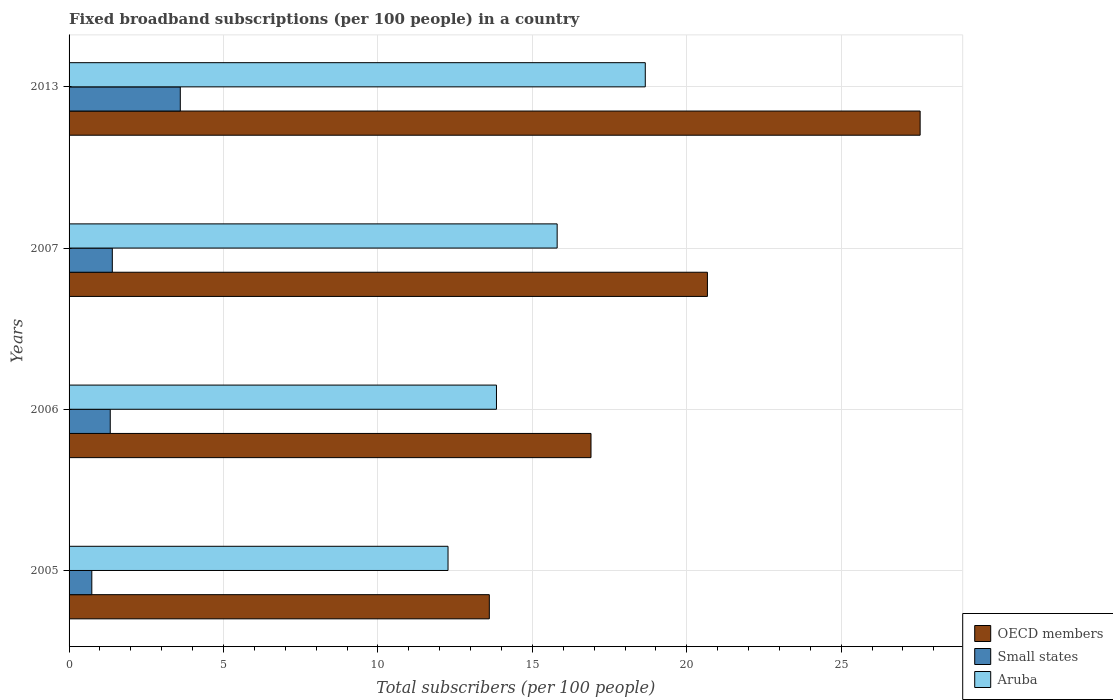How many groups of bars are there?
Offer a terse response. 4. How many bars are there on the 4th tick from the top?
Make the answer very short. 3. What is the label of the 1st group of bars from the top?
Your answer should be very brief. 2013. In how many cases, is the number of bars for a given year not equal to the number of legend labels?
Offer a terse response. 0. What is the number of broadband subscriptions in OECD members in 2006?
Your answer should be compact. 16.9. Across all years, what is the maximum number of broadband subscriptions in Aruba?
Make the answer very short. 18.66. Across all years, what is the minimum number of broadband subscriptions in OECD members?
Offer a terse response. 13.61. In which year was the number of broadband subscriptions in Small states maximum?
Your answer should be compact. 2013. In which year was the number of broadband subscriptions in Aruba minimum?
Make the answer very short. 2005. What is the total number of broadband subscriptions in Aruba in the graph?
Provide a short and direct response. 60.57. What is the difference between the number of broadband subscriptions in Small states in 2005 and that in 2013?
Give a very brief answer. -2.86. What is the difference between the number of broadband subscriptions in OECD members in 2006 and the number of broadband subscriptions in Small states in 2005?
Offer a terse response. 16.16. What is the average number of broadband subscriptions in OECD members per year?
Your answer should be compact. 19.68. In the year 2013, what is the difference between the number of broadband subscriptions in Aruba and number of broadband subscriptions in OECD members?
Ensure brevity in your answer.  -8.9. What is the ratio of the number of broadband subscriptions in Aruba in 2005 to that in 2007?
Offer a terse response. 0.78. Is the number of broadband subscriptions in Small states in 2006 less than that in 2013?
Make the answer very short. Yes. What is the difference between the highest and the second highest number of broadband subscriptions in Aruba?
Give a very brief answer. 2.85. What is the difference between the highest and the lowest number of broadband subscriptions in Aruba?
Your answer should be very brief. 6.39. Is the sum of the number of broadband subscriptions in OECD members in 2006 and 2007 greater than the maximum number of broadband subscriptions in Aruba across all years?
Keep it short and to the point. Yes. What does the 1st bar from the top in 2007 represents?
Your answer should be very brief. Aruba. Is it the case that in every year, the sum of the number of broadband subscriptions in OECD members and number of broadband subscriptions in Aruba is greater than the number of broadband subscriptions in Small states?
Your answer should be compact. Yes. Are all the bars in the graph horizontal?
Your answer should be very brief. Yes. What is the difference between two consecutive major ticks on the X-axis?
Make the answer very short. 5. Does the graph contain any zero values?
Keep it short and to the point. No. How many legend labels are there?
Your answer should be compact. 3. How are the legend labels stacked?
Your answer should be very brief. Vertical. What is the title of the graph?
Your answer should be very brief. Fixed broadband subscriptions (per 100 people) in a country. Does "Ireland" appear as one of the legend labels in the graph?
Offer a very short reply. No. What is the label or title of the X-axis?
Keep it short and to the point. Total subscribers (per 100 people). What is the Total subscribers (per 100 people) of OECD members in 2005?
Provide a succinct answer. 13.61. What is the Total subscribers (per 100 people) in Small states in 2005?
Provide a succinct answer. 0.74. What is the Total subscribers (per 100 people) in Aruba in 2005?
Make the answer very short. 12.27. What is the Total subscribers (per 100 people) in OECD members in 2006?
Offer a very short reply. 16.9. What is the Total subscribers (per 100 people) in Small states in 2006?
Keep it short and to the point. 1.33. What is the Total subscribers (per 100 people) of Aruba in 2006?
Ensure brevity in your answer.  13.84. What is the Total subscribers (per 100 people) of OECD members in 2007?
Your answer should be very brief. 20.67. What is the Total subscribers (per 100 people) of Small states in 2007?
Keep it short and to the point. 1.4. What is the Total subscribers (per 100 people) of Aruba in 2007?
Offer a very short reply. 15.8. What is the Total subscribers (per 100 people) of OECD members in 2013?
Provide a short and direct response. 27.56. What is the Total subscribers (per 100 people) of Small states in 2013?
Ensure brevity in your answer.  3.6. What is the Total subscribers (per 100 people) of Aruba in 2013?
Offer a terse response. 18.66. Across all years, what is the maximum Total subscribers (per 100 people) in OECD members?
Your response must be concise. 27.56. Across all years, what is the maximum Total subscribers (per 100 people) in Small states?
Give a very brief answer. 3.6. Across all years, what is the maximum Total subscribers (per 100 people) of Aruba?
Your answer should be very brief. 18.66. Across all years, what is the minimum Total subscribers (per 100 people) in OECD members?
Provide a succinct answer. 13.61. Across all years, what is the minimum Total subscribers (per 100 people) of Small states?
Your answer should be compact. 0.74. Across all years, what is the minimum Total subscribers (per 100 people) in Aruba?
Ensure brevity in your answer.  12.27. What is the total Total subscribers (per 100 people) of OECD members in the graph?
Your answer should be very brief. 78.73. What is the total Total subscribers (per 100 people) in Small states in the graph?
Make the answer very short. 7.07. What is the total Total subscribers (per 100 people) of Aruba in the graph?
Your answer should be compact. 60.57. What is the difference between the Total subscribers (per 100 people) of OECD members in 2005 and that in 2006?
Offer a very short reply. -3.29. What is the difference between the Total subscribers (per 100 people) in Small states in 2005 and that in 2006?
Offer a terse response. -0.6. What is the difference between the Total subscribers (per 100 people) in Aruba in 2005 and that in 2006?
Provide a short and direct response. -1.57. What is the difference between the Total subscribers (per 100 people) in OECD members in 2005 and that in 2007?
Make the answer very short. -7.06. What is the difference between the Total subscribers (per 100 people) of Small states in 2005 and that in 2007?
Provide a short and direct response. -0.66. What is the difference between the Total subscribers (per 100 people) of Aruba in 2005 and that in 2007?
Your answer should be very brief. -3.53. What is the difference between the Total subscribers (per 100 people) in OECD members in 2005 and that in 2013?
Provide a short and direct response. -13.95. What is the difference between the Total subscribers (per 100 people) of Small states in 2005 and that in 2013?
Provide a succinct answer. -2.87. What is the difference between the Total subscribers (per 100 people) of Aruba in 2005 and that in 2013?
Your answer should be compact. -6.39. What is the difference between the Total subscribers (per 100 people) in OECD members in 2006 and that in 2007?
Give a very brief answer. -3.77. What is the difference between the Total subscribers (per 100 people) of Small states in 2006 and that in 2007?
Provide a short and direct response. -0.07. What is the difference between the Total subscribers (per 100 people) in Aruba in 2006 and that in 2007?
Give a very brief answer. -1.97. What is the difference between the Total subscribers (per 100 people) of OECD members in 2006 and that in 2013?
Your response must be concise. -10.66. What is the difference between the Total subscribers (per 100 people) in Small states in 2006 and that in 2013?
Your answer should be very brief. -2.27. What is the difference between the Total subscribers (per 100 people) in Aruba in 2006 and that in 2013?
Your answer should be compact. -4.82. What is the difference between the Total subscribers (per 100 people) in OECD members in 2007 and that in 2013?
Ensure brevity in your answer.  -6.89. What is the difference between the Total subscribers (per 100 people) of Small states in 2007 and that in 2013?
Offer a very short reply. -2.2. What is the difference between the Total subscribers (per 100 people) in Aruba in 2007 and that in 2013?
Your response must be concise. -2.85. What is the difference between the Total subscribers (per 100 people) in OECD members in 2005 and the Total subscribers (per 100 people) in Small states in 2006?
Ensure brevity in your answer.  12.27. What is the difference between the Total subscribers (per 100 people) of OECD members in 2005 and the Total subscribers (per 100 people) of Aruba in 2006?
Make the answer very short. -0.23. What is the difference between the Total subscribers (per 100 people) in Small states in 2005 and the Total subscribers (per 100 people) in Aruba in 2006?
Make the answer very short. -13.1. What is the difference between the Total subscribers (per 100 people) of OECD members in 2005 and the Total subscribers (per 100 people) of Small states in 2007?
Provide a succinct answer. 12.21. What is the difference between the Total subscribers (per 100 people) in OECD members in 2005 and the Total subscribers (per 100 people) in Aruba in 2007?
Your response must be concise. -2.2. What is the difference between the Total subscribers (per 100 people) in Small states in 2005 and the Total subscribers (per 100 people) in Aruba in 2007?
Your answer should be very brief. -15.07. What is the difference between the Total subscribers (per 100 people) of OECD members in 2005 and the Total subscribers (per 100 people) of Small states in 2013?
Give a very brief answer. 10.01. What is the difference between the Total subscribers (per 100 people) of OECD members in 2005 and the Total subscribers (per 100 people) of Aruba in 2013?
Provide a succinct answer. -5.05. What is the difference between the Total subscribers (per 100 people) of Small states in 2005 and the Total subscribers (per 100 people) of Aruba in 2013?
Provide a succinct answer. -17.92. What is the difference between the Total subscribers (per 100 people) in OECD members in 2006 and the Total subscribers (per 100 people) in Small states in 2007?
Provide a short and direct response. 15.5. What is the difference between the Total subscribers (per 100 people) of OECD members in 2006 and the Total subscribers (per 100 people) of Aruba in 2007?
Ensure brevity in your answer.  1.1. What is the difference between the Total subscribers (per 100 people) of Small states in 2006 and the Total subscribers (per 100 people) of Aruba in 2007?
Your response must be concise. -14.47. What is the difference between the Total subscribers (per 100 people) in OECD members in 2006 and the Total subscribers (per 100 people) in Small states in 2013?
Keep it short and to the point. 13.3. What is the difference between the Total subscribers (per 100 people) in OECD members in 2006 and the Total subscribers (per 100 people) in Aruba in 2013?
Provide a short and direct response. -1.76. What is the difference between the Total subscribers (per 100 people) in Small states in 2006 and the Total subscribers (per 100 people) in Aruba in 2013?
Provide a short and direct response. -17.32. What is the difference between the Total subscribers (per 100 people) of OECD members in 2007 and the Total subscribers (per 100 people) of Small states in 2013?
Provide a short and direct response. 17.07. What is the difference between the Total subscribers (per 100 people) in OECD members in 2007 and the Total subscribers (per 100 people) in Aruba in 2013?
Make the answer very short. 2.01. What is the difference between the Total subscribers (per 100 people) of Small states in 2007 and the Total subscribers (per 100 people) of Aruba in 2013?
Your answer should be very brief. -17.26. What is the average Total subscribers (per 100 people) in OECD members per year?
Your answer should be compact. 19.68. What is the average Total subscribers (per 100 people) in Small states per year?
Give a very brief answer. 1.77. What is the average Total subscribers (per 100 people) of Aruba per year?
Provide a succinct answer. 15.14. In the year 2005, what is the difference between the Total subscribers (per 100 people) in OECD members and Total subscribers (per 100 people) in Small states?
Provide a succinct answer. 12.87. In the year 2005, what is the difference between the Total subscribers (per 100 people) in OECD members and Total subscribers (per 100 people) in Aruba?
Your answer should be compact. 1.34. In the year 2005, what is the difference between the Total subscribers (per 100 people) of Small states and Total subscribers (per 100 people) of Aruba?
Provide a short and direct response. -11.53. In the year 2006, what is the difference between the Total subscribers (per 100 people) of OECD members and Total subscribers (per 100 people) of Small states?
Offer a very short reply. 15.57. In the year 2006, what is the difference between the Total subscribers (per 100 people) of OECD members and Total subscribers (per 100 people) of Aruba?
Ensure brevity in your answer.  3.06. In the year 2006, what is the difference between the Total subscribers (per 100 people) in Small states and Total subscribers (per 100 people) in Aruba?
Offer a terse response. -12.5. In the year 2007, what is the difference between the Total subscribers (per 100 people) in OECD members and Total subscribers (per 100 people) in Small states?
Provide a short and direct response. 19.27. In the year 2007, what is the difference between the Total subscribers (per 100 people) in OECD members and Total subscribers (per 100 people) in Aruba?
Ensure brevity in your answer.  4.87. In the year 2007, what is the difference between the Total subscribers (per 100 people) of Small states and Total subscribers (per 100 people) of Aruba?
Give a very brief answer. -14.4. In the year 2013, what is the difference between the Total subscribers (per 100 people) in OECD members and Total subscribers (per 100 people) in Small states?
Provide a short and direct response. 23.95. In the year 2013, what is the difference between the Total subscribers (per 100 people) of OECD members and Total subscribers (per 100 people) of Aruba?
Provide a succinct answer. 8.9. In the year 2013, what is the difference between the Total subscribers (per 100 people) in Small states and Total subscribers (per 100 people) in Aruba?
Make the answer very short. -15.06. What is the ratio of the Total subscribers (per 100 people) in OECD members in 2005 to that in 2006?
Provide a short and direct response. 0.81. What is the ratio of the Total subscribers (per 100 people) in Small states in 2005 to that in 2006?
Your answer should be compact. 0.55. What is the ratio of the Total subscribers (per 100 people) of Aruba in 2005 to that in 2006?
Make the answer very short. 0.89. What is the ratio of the Total subscribers (per 100 people) of OECD members in 2005 to that in 2007?
Give a very brief answer. 0.66. What is the ratio of the Total subscribers (per 100 people) of Small states in 2005 to that in 2007?
Keep it short and to the point. 0.53. What is the ratio of the Total subscribers (per 100 people) in Aruba in 2005 to that in 2007?
Your answer should be very brief. 0.78. What is the ratio of the Total subscribers (per 100 people) in OECD members in 2005 to that in 2013?
Your response must be concise. 0.49. What is the ratio of the Total subscribers (per 100 people) of Small states in 2005 to that in 2013?
Provide a succinct answer. 0.2. What is the ratio of the Total subscribers (per 100 people) of Aruba in 2005 to that in 2013?
Give a very brief answer. 0.66. What is the ratio of the Total subscribers (per 100 people) of OECD members in 2006 to that in 2007?
Give a very brief answer. 0.82. What is the ratio of the Total subscribers (per 100 people) of Small states in 2006 to that in 2007?
Your response must be concise. 0.95. What is the ratio of the Total subscribers (per 100 people) in Aruba in 2006 to that in 2007?
Provide a succinct answer. 0.88. What is the ratio of the Total subscribers (per 100 people) of OECD members in 2006 to that in 2013?
Provide a succinct answer. 0.61. What is the ratio of the Total subscribers (per 100 people) of Small states in 2006 to that in 2013?
Your answer should be very brief. 0.37. What is the ratio of the Total subscribers (per 100 people) in Aruba in 2006 to that in 2013?
Offer a terse response. 0.74. What is the ratio of the Total subscribers (per 100 people) of OECD members in 2007 to that in 2013?
Your response must be concise. 0.75. What is the ratio of the Total subscribers (per 100 people) in Small states in 2007 to that in 2013?
Give a very brief answer. 0.39. What is the ratio of the Total subscribers (per 100 people) in Aruba in 2007 to that in 2013?
Ensure brevity in your answer.  0.85. What is the difference between the highest and the second highest Total subscribers (per 100 people) in OECD members?
Offer a terse response. 6.89. What is the difference between the highest and the second highest Total subscribers (per 100 people) in Small states?
Provide a short and direct response. 2.2. What is the difference between the highest and the second highest Total subscribers (per 100 people) in Aruba?
Provide a succinct answer. 2.85. What is the difference between the highest and the lowest Total subscribers (per 100 people) in OECD members?
Keep it short and to the point. 13.95. What is the difference between the highest and the lowest Total subscribers (per 100 people) in Small states?
Your answer should be compact. 2.87. What is the difference between the highest and the lowest Total subscribers (per 100 people) in Aruba?
Provide a short and direct response. 6.39. 